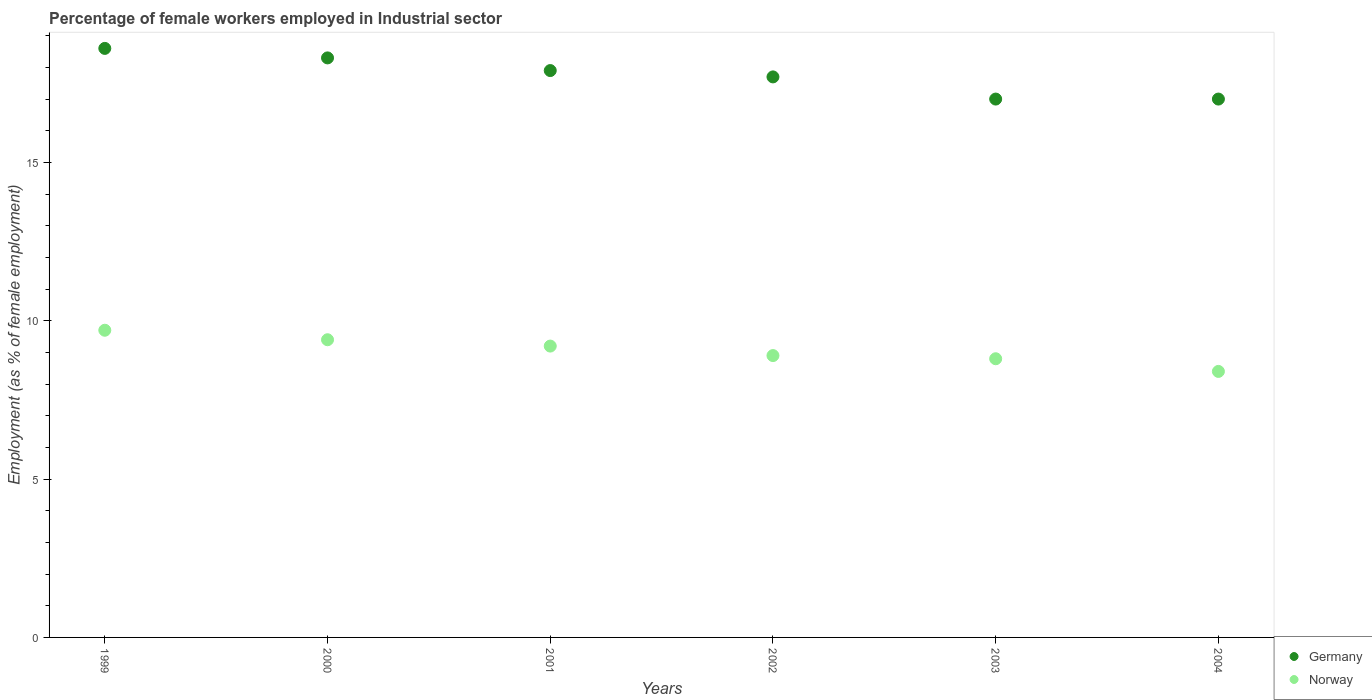How many different coloured dotlines are there?
Give a very brief answer. 2. What is the percentage of females employed in Industrial sector in Germany in 2003?
Offer a very short reply. 17. Across all years, what is the maximum percentage of females employed in Industrial sector in Norway?
Your response must be concise. 9.7. Across all years, what is the minimum percentage of females employed in Industrial sector in Norway?
Offer a terse response. 8.4. In which year was the percentage of females employed in Industrial sector in Norway minimum?
Provide a succinct answer. 2004. What is the total percentage of females employed in Industrial sector in Germany in the graph?
Provide a succinct answer. 106.5. What is the difference between the percentage of females employed in Industrial sector in Norway in 2002 and that in 2004?
Your response must be concise. 0.5. What is the difference between the percentage of females employed in Industrial sector in Norway in 1999 and the percentage of females employed in Industrial sector in Germany in 2000?
Offer a very short reply. -8.6. What is the average percentage of females employed in Industrial sector in Germany per year?
Make the answer very short. 17.75. In the year 2004, what is the difference between the percentage of females employed in Industrial sector in Germany and percentage of females employed in Industrial sector in Norway?
Make the answer very short. 8.6. In how many years, is the percentage of females employed in Industrial sector in Norway greater than 15 %?
Offer a very short reply. 0. What is the ratio of the percentage of females employed in Industrial sector in Norway in 2001 to that in 2002?
Offer a very short reply. 1.03. Is the difference between the percentage of females employed in Industrial sector in Germany in 1999 and 2000 greater than the difference between the percentage of females employed in Industrial sector in Norway in 1999 and 2000?
Keep it short and to the point. Yes. What is the difference between the highest and the second highest percentage of females employed in Industrial sector in Germany?
Keep it short and to the point. 0.3. What is the difference between the highest and the lowest percentage of females employed in Industrial sector in Germany?
Give a very brief answer. 1.6. In how many years, is the percentage of females employed in Industrial sector in Norway greater than the average percentage of females employed in Industrial sector in Norway taken over all years?
Your response must be concise. 3. How many dotlines are there?
Your answer should be compact. 2. How many years are there in the graph?
Offer a terse response. 6. Are the values on the major ticks of Y-axis written in scientific E-notation?
Give a very brief answer. No. Does the graph contain any zero values?
Ensure brevity in your answer.  No. Where does the legend appear in the graph?
Keep it short and to the point. Bottom right. How many legend labels are there?
Your answer should be compact. 2. What is the title of the graph?
Ensure brevity in your answer.  Percentage of female workers employed in Industrial sector. What is the label or title of the Y-axis?
Offer a very short reply. Employment (as % of female employment). What is the Employment (as % of female employment) of Germany in 1999?
Offer a terse response. 18.6. What is the Employment (as % of female employment) in Norway in 1999?
Give a very brief answer. 9.7. What is the Employment (as % of female employment) in Germany in 2000?
Your answer should be very brief. 18.3. What is the Employment (as % of female employment) in Norway in 2000?
Your response must be concise. 9.4. What is the Employment (as % of female employment) of Germany in 2001?
Provide a succinct answer. 17.9. What is the Employment (as % of female employment) of Norway in 2001?
Your response must be concise. 9.2. What is the Employment (as % of female employment) of Germany in 2002?
Offer a very short reply. 17.7. What is the Employment (as % of female employment) in Norway in 2002?
Offer a very short reply. 8.9. What is the Employment (as % of female employment) in Germany in 2003?
Keep it short and to the point. 17. What is the Employment (as % of female employment) in Norway in 2003?
Make the answer very short. 8.8. What is the Employment (as % of female employment) of Germany in 2004?
Your answer should be compact. 17. What is the Employment (as % of female employment) of Norway in 2004?
Provide a succinct answer. 8.4. Across all years, what is the maximum Employment (as % of female employment) in Germany?
Provide a succinct answer. 18.6. Across all years, what is the maximum Employment (as % of female employment) in Norway?
Make the answer very short. 9.7. Across all years, what is the minimum Employment (as % of female employment) of Norway?
Offer a terse response. 8.4. What is the total Employment (as % of female employment) of Germany in the graph?
Your response must be concise. 106.5. What is the total Employment (as % of female employment) of Norway in the graph?
Your answer should be very brief. 54.4. What is the difference between the Employment (as % of female employment) of Germany in 1999 and that in 2000?
Make the answer very short. 0.3. What is the difference between the Employment (as % of female employment) in Norway in 1999 and that in 2000?
Provide a succinct answer. 0.3. What is the difference between the Employment (as % of female employment) of Norway in 1999 and that in 2001?
Offer a very short reply. 0.5. What is the difference between the Employment (as % of female employment) of Germany in 1999 and that in 2002?
Offer a terse response. 0.9. What is the difference between the Employment (as % of female employment) in Norway in 1999 and that in 2002?
Offer a very short reply. 0.8. What is the difference between the Employment (as % of female employment) of Germany in 1999 and that in 2004?
Your answer should be compact. 1.6. What is the difference between the Employment (as % of female employment) in Norway in 1999 and that in 2004?
Offer a terse response. 1.3. What is the difference between the Employment (as % of female employment) of Norway in 2000 and that in 2003?
Your answer should be compact. 0.6. What is the difference between the Employment (as % of female employment) in Germany in 2000 and that in 2004?
Ensure brevity in your answer.  1.3. What is the difference between the Employment (as % of female employment) of Norway in 2001 and that in 2002?
Make the answer very short. 0.3. What is the difference between the Employment (as % of female employment) in Norway in 2001 and that in 2003?
Provide a succinct answer. 0.4. What is the difference between the Employment (as % of female employment) in Germany in 2001 and that in 2004?
Provide a succinct answer. 0.9. What is the difference between the Employment (as % of female employment) of Norway in 2001 and that in 2004?
Make the answer very short. 0.8. What is the difference between the Employment (as % of female employment) of Germany in 2002 and that in 2003?
Ensure brevity in your answer.  0.7. What is the difference between the Employment (as % of female employment) of Norway in 2002 and that in 2003?
Give a very brief answer. 0.1. What is the difference between the Employment (as % of female employment) of Norway in 2002 and that in 2004?
Your answer should be compact. 0.5. What is the difference between the Employment (as % of female employment) of Germany in 1999 and the Employment (as % of female employment) of Norway in 2000?
Ensure brevity in your answer.  9.2. What is the difference between the Employment (as % of female employment) of Germany in 1999 and the Employment (as % of female employment) of Norway in 2002?
Offer a terse response. 9.7. What is the difference between the Employment (as % of female employment) in Germany in 1999 and the Employment (as % of female employment) in Norway in 2003?
Provide a short and direct response. 9.8. What is the difference between the Employment (as % of female employment) of Germany in 1999 and the Employment (as % of female employment) of Norway in 2004?
Make the answer very short. 10.2. What is the difference between the Employment (as % of female employment) of Germany in 2001 and the Employment (as % of female employment) of Norway in 2002?
Your response must be concise. 9. What is the difference between the Employment (as % of female employment) in Germany in 2001 and the Employment (as % of female employment) in Norway in 2003?
Offer a terse response. 9.1. What is the average Employment (as % of female employment) in Germany per year?
Your response must be concise. 17.75. What is the average Employment (as % of female employment) in Norway per year?
Keep it short and to the point. 9.07. In the year 1999, what is the difference between the Employment (as % of female employment) in Germany and Employment (as % of female employment) in Norway?
Offer a terse response. 8.9. In the year 2000, what is the difference between the Employment (as % of female employment) in Germany and Employment (as % of female employment) in Norway?
Keep it short and to the point. 8.9. In the year 2001, what is the difference between the Employment (as % of female employment) in Germany and Employment (as % of female employment) in Norway?
Keep it short and to the point. 8.7. In the year 2002, what is the difference between the Employment (as % of female employment) in Germany and Employment (as % of female employment) in Norway?
Provide a succinct answer. 8.8. In the year 2003, what is the difference between the Employment (as % of female employment) in Germany and Employment (as % of female employment) in Norway?
Keep it short and to the point. 8.2. In the year 2004, what is the difference between the Employment (as % of female employment) of Germany and Employment (as % of female employment) of Norway?
Keep it short and to the point. 8.6. What is the ratio of the Employment (as % of female employment) in Germany in 1999 to that in 2000?
Offer a very short reply. 1.02. What is the ratio of the Employment (as % of female employment) in Norway in 1999 to that in 2000?
Ensure brevity in your answer.  1.03. What is the ratio of the Employment (as % of female employment) of Germany in 1999 to that in 2001?
Provide a short and direct response. 1.04. What is the ratio of the Employment (as % of female employment) in Norway in 1999 to that in 2001?
Your answer should be compact. 1.05. What is the ratio of the Employment (as % of female employment) in Germany in 1999 to that in 2002?
Give a very brief answer. 1.05. What is the ratio of the Employment (as % of female employment) of Norway in 1999 to that in 2002?
Ensure brevity in your answer.  1.09. What is the ratio of the Employment (as % of female employment) of Germany in 1999 to that in 2003?
Make the answer very short. 1.09. What is the ratio of the Employment (as % of female employment) in Norway in 1999 to that in 2003?
Make the answer very short. 1.1. What is the ratio of the Employment (as % of female employment) of Germany in 1999 to that in 2004?
Provide a succinct answer. 1.09. What is the ratio of the Employment (as % of female employment) in Norway in 1999 to that in 2004?
Ensure brevity in your answer.  1.15. What is the ratio of the Employment (as % of female employment) in Germany in 2000 to that in 2001?
Provide a succinct answer. 1.02. What is the ratio of the Employment (as % of female employment) of Norway in 2000 to that in 2001?
Offer a terse response. 1.02. What is the ratio of the Employment (as % of female employment) of Germany in 2000 to that in 2002?
Ensure brevity in your answer.  1.03. What is the ratio of the Employment (as % of female employment) in Norway in 2000 to that in 2002?
Your response must be concise. 1.06. What is the ratio of the Employment (as % of female employment) of Germany in 2000 to that in 2003?
Make the answer very short. 1.08. What is the ratio of the Employment (as % of female employment) in Norway in 2000 to that in 2003?
Provide a short and direct response. 1.07. What is the ratio of the Employment (as % of female employment) in Germany in 2000 to that in 2004?
Your answer should be compact. 1.08. What is the ratio of the Employment (as % of female employment) of Norway in 2000 to that in 2004?
Give a very brief answer. 1.12. What is the ratio of the Employment (as % of female employment) of Germany in 2001 to that in 2002?
Give a very brief answer. 1.01. What is the ratio of the Employment (as % of female employment) of Norway in 2001 to that in 2002?
Your response must be concise. 1.03. What is the ratio of the Employment (as % of female employment) in Germany in 2001 to that in 2003?
Offer a terse response. 1.05. What is the ratio of the Employment (as % of female employment) in Norway in 2001 to that in 2003?
Provide a succinct answer. 1.05. What is the ratio of the Employment (as % of female employment) in Germany in 2001 to that in 2004?
Ensure brevity in your answer.  1.05. What is the ratio of the Employment (as % of female employment) of Norway in 2001 to that in 2004?
Ensure brevity in your answer.  1.1. What is the ratio of the Employment (as % of female employment) of Germany in 2002 to that in 2003?
Your response must be concise. 1.04. What is the ratio of the Employment (as % of female employment) of Norway in 2002 to that in 2003?
Offer a very short reply. 1.01. What is the ratio of the Employment (as % of female employment) of Germany in 2002 to that in 2004?
Offer a very short reply. 1.04. What is the ratio of the Employment (as % of female employment) in Norway in 2002 to that in 2004?
Your response must be concise. 1.06. What is the ratio of the Employment (as % of female employment) in Germany in 2003 to that in 2004?
Offer a terse response. 1. What is the ratio of the Employment (as % of female employment) in Norway in 2003 to that in 2004?
Offer a very short reply. 1.05. What is the difference between the highest and the second highest Employment (as % of female employment) of Norway?
Ensure brevity in your answer.  0.3. What is the difference between the highest and the lowest Employment (as % of female employment) in Germany?
Offer a very short reply. 1.6. 